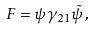Convert formula to latex. <formula><loc_0><loc_0><loc_500><loc_500>F = \psi \gamma _ { 2 1 } \tilde { \psi } \, ,</formula> 